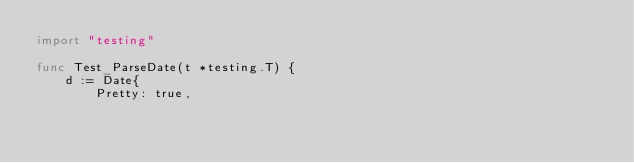Convert code to text. <code><loc_0><loc_0><loc_500><loc_500><_Go_>import "testing"

func Test_ParseDate(t *testing.T) {
	d := Date{
		Pretty: true,</code> 